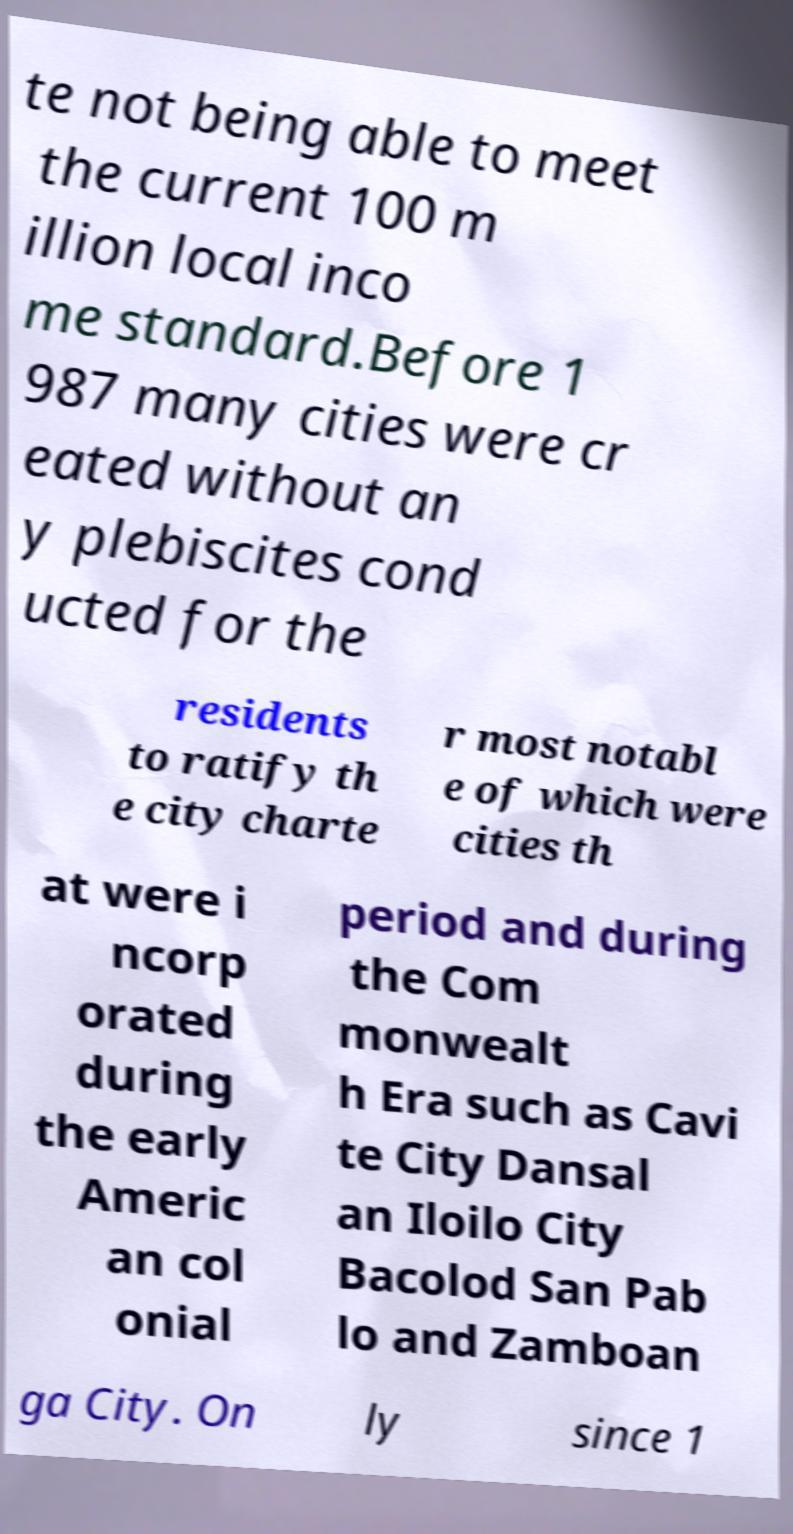Could you assist in decoding the text presented in this image and type it out clearly? te not being able to meet the current 100 m illion local inco me standard.Before 1 987 many cities were cr eated without an y plebiscites cond ucted for the residents to ratify th e city charte r most notabl e of which were cities th at were i ncorp orated during the early Americ an col onial period and during the Com monwealt h Era such as Cavi te City Dansal an Iloilo City Bacolod San Pab lo and Zamboan ga City. On ly since 1 